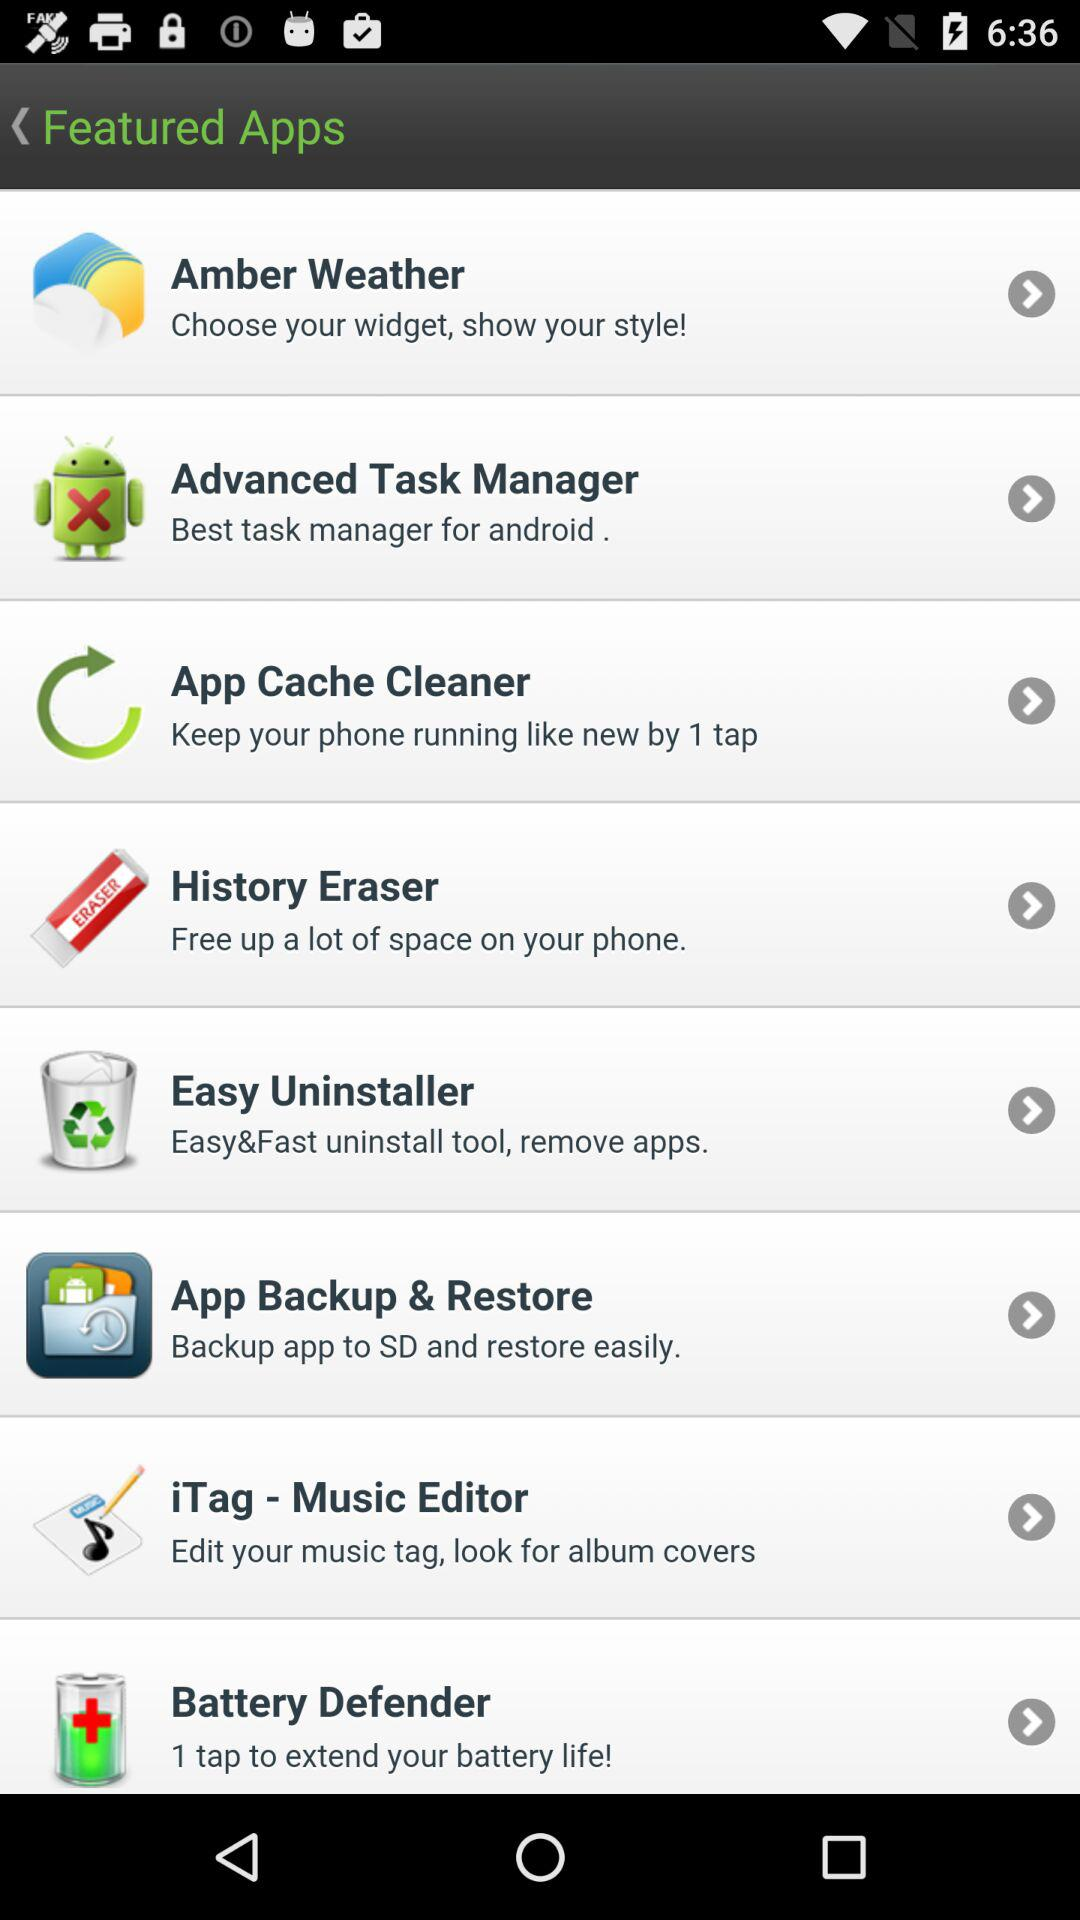What is the name of the application that has the best task manager for Android? The name of the application is Advanced Task Manager. 